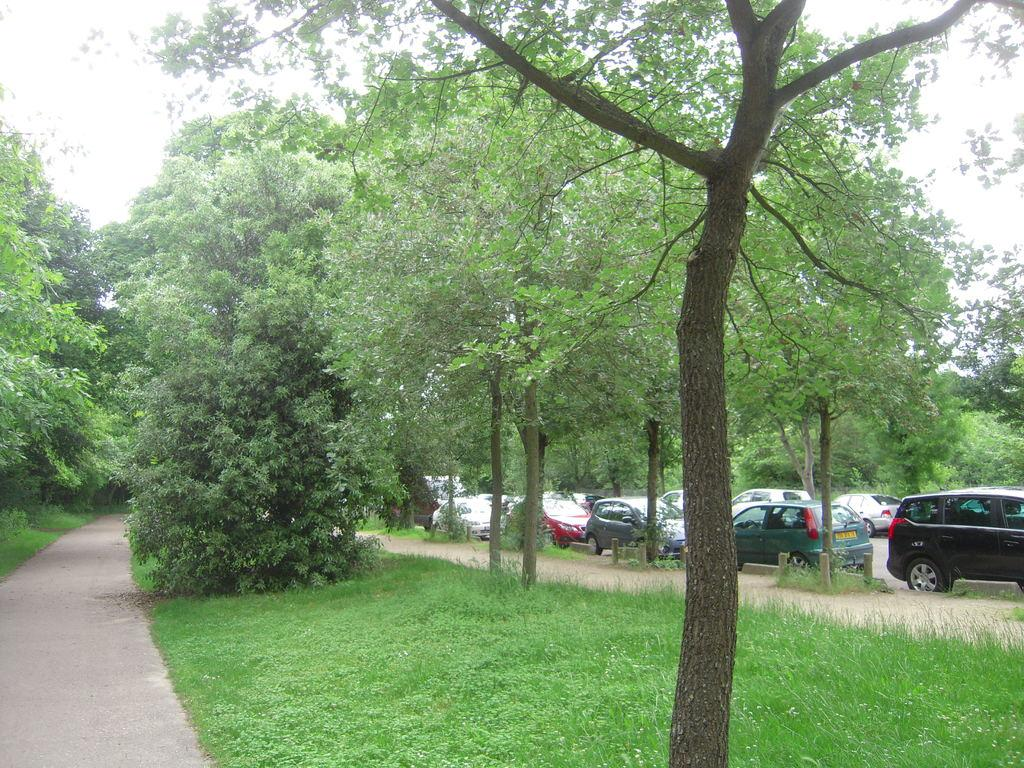What is located in the center of the image? There are trees, grass, a road, and vehicles in the center of the image. What type of vegetation can be seen in the image? Trees and grass are visible in the image. What is the condition of the road in the image? The road is in the center of the image. What can be seen in the background of the image? The sky and clouds are visible in the background of the image. What type of beef is being served at the picnic in the image? There is no picnic or beef present in the image; it features trees, grass, a road, vehicles, and a sky with clouds. How does the leather feel in the image? There is no leather present in the image. 